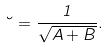Convert formula to latex. <formula><loc_0><loc_0><loc_500><loc_500>\lambda = \frac { 1 } { \sqrt { A + B } } .</formula> 